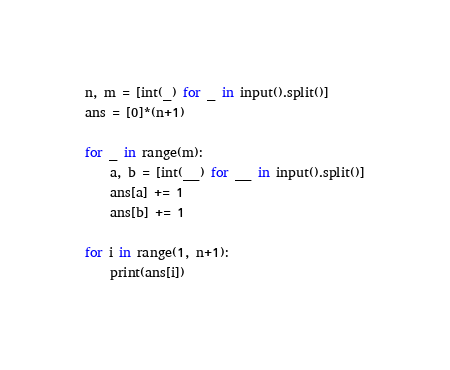<code> <loc_0><loc_0><loc_500><loc_500><_Python_>n, m = [int(_) for _ in input().split()]
ans = [0]*(n+1)

for _ in range(m):
    a, b = [int(__) for __ in input().split()]
    ans[a] += 1
    ans[b] += 1

for i in range(1, n+1):
    print(ans[i])
</code> 